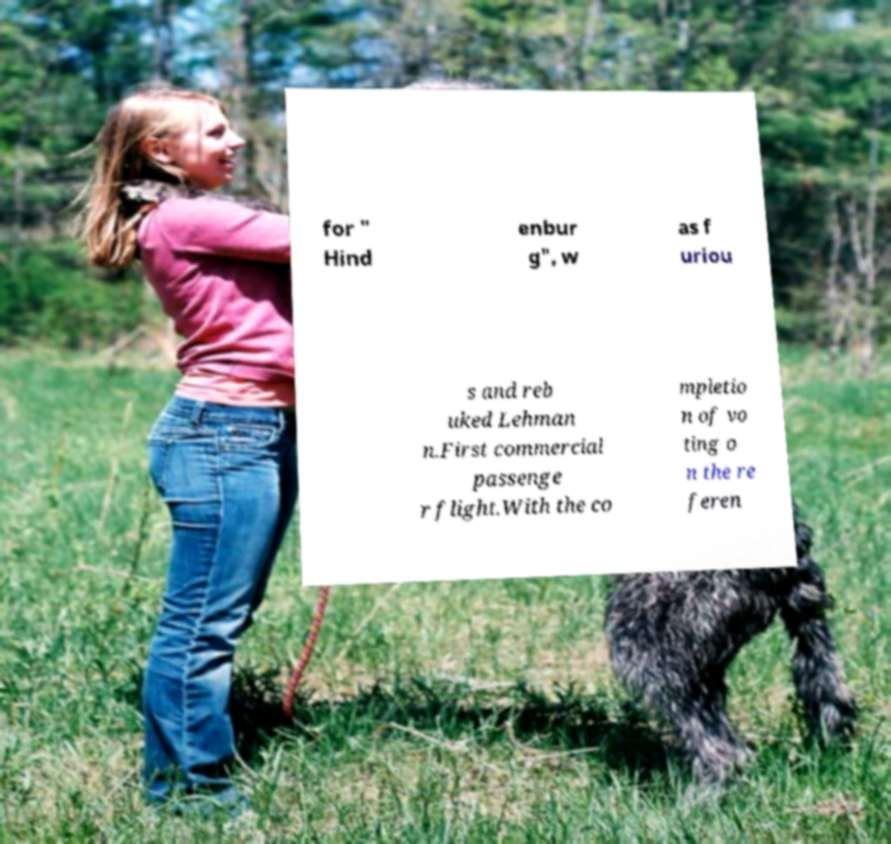Please identify and transcribe the text found in this image. for " Hind enbur g", w as f uriou s and reb uked Lehman n.First commercial passenge r flight.With the co mpletio n of vo ting o n the re feren 